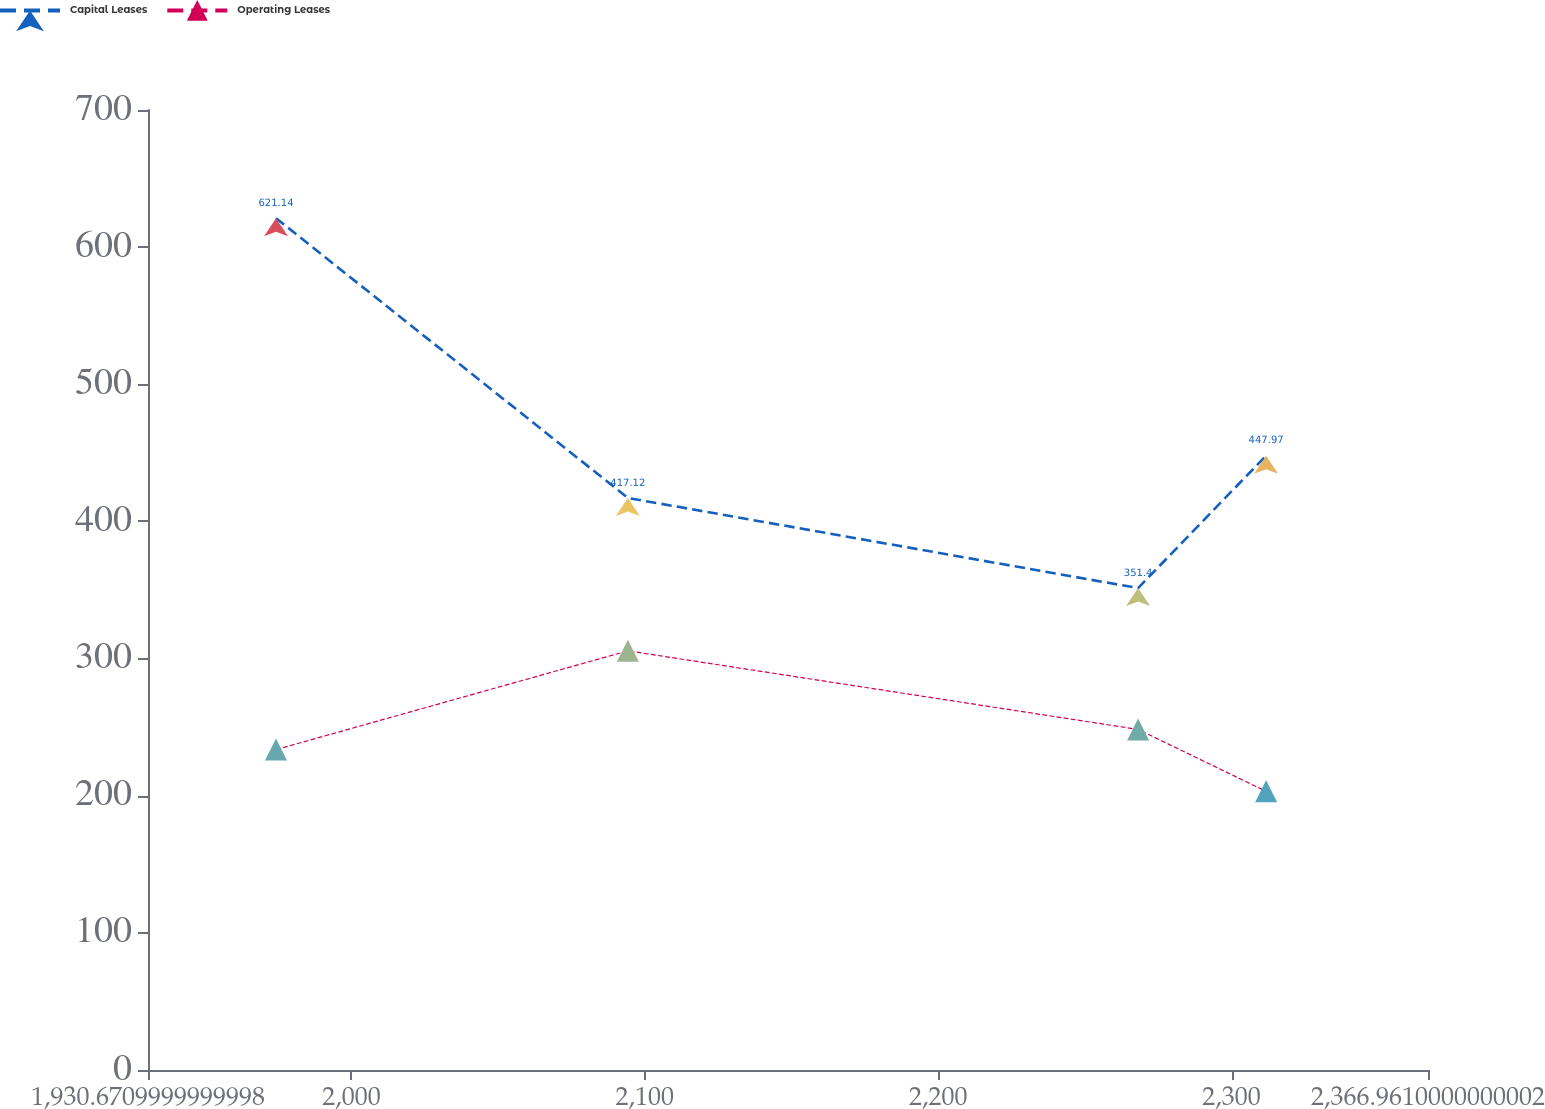Convert chart to OTSL. <chart><loc_0><loc_0><loc_500><loc_500><line_chart><ecel><fcel>Capital Leases<fcel>Operating Leases<nl><fcel>1974.3<fcel>621.14<fcel>233.61<nl><fcel>2094.23<fcel>417.12<fcel>305.64<nl><fcel>2268.15<fcel>351.4<fcel>248.34<nl><fcel>2311.78<fcel>447.97<fcel>203.17<nl><fcel>2410.59<fcel>312.63<fcel>288.04<nl></chart> 